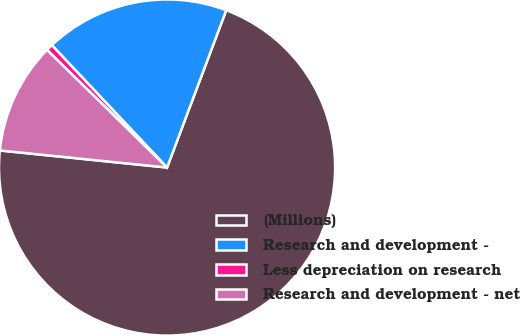<chart> <loc_0><loc_0><loc_500><loc_500><pie_chart><fcel>(Millions)<fcel>Research and development -<fcel>Less depreciation on research<fcel>Research and development - net<nl><fcel>70.9%<fcel>17.75%<fcel>0.64%<fcel>10.72%<nl></chart> 